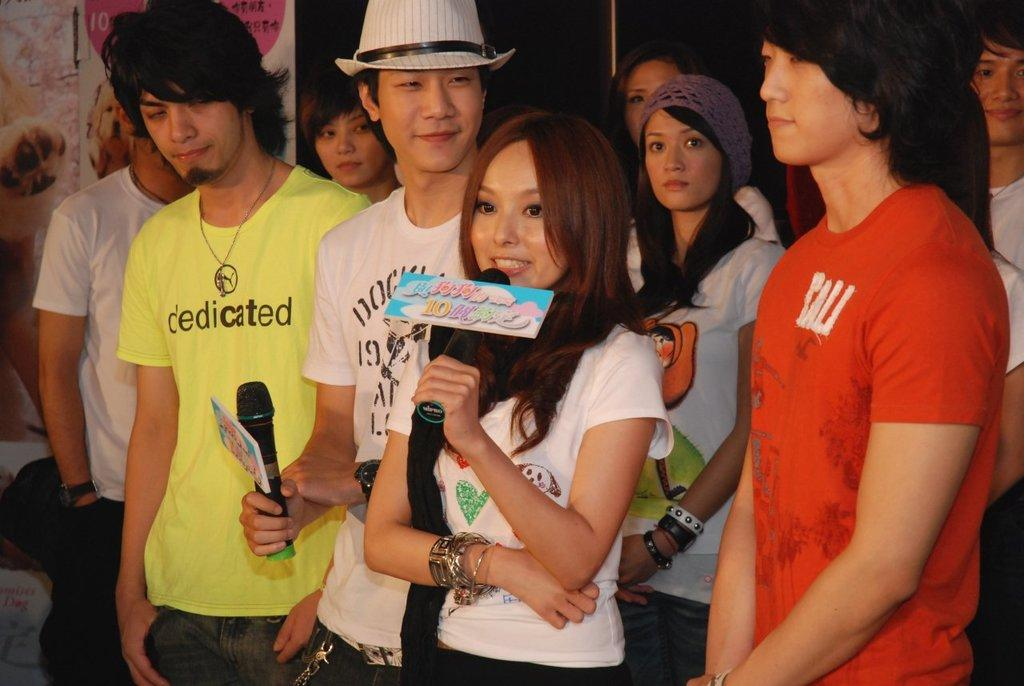What is happening in the image? There are persons standing in the image. What are two of the persons holding? Two persons are holding microphones in their hands. Can you describe the attire of one of the persons? One person is wearing a hat. What type of cup is the person holding in the image? There is no cup present in the image; the persons are holding microphones. 